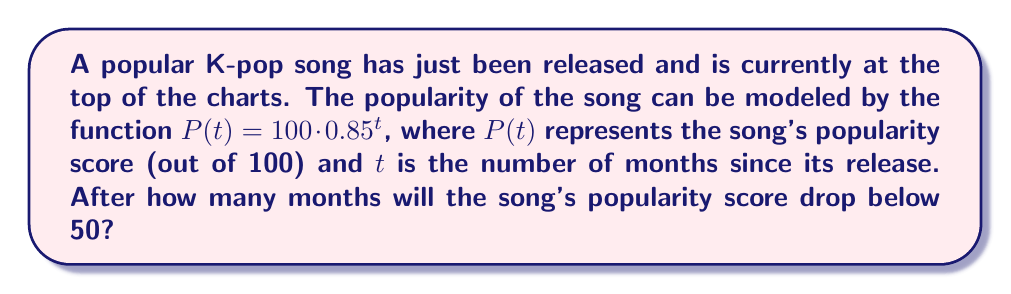Help me with this question. To solve this problem, we need to use logarithms to find the value of $t$ when $P(t) < 50$. Let's follow these steps:

1) We want to find $t$ when $P(t) = 50$, as this is the point where the popularity drops below 50.

2) Set up the equation:
   $50 = 100 \cdot 0.85^t$

3) Divide both sides by 100:
   $0.5 = 0.85^t$

4) Take the natural logarithm of both sides:
   $\ln(0.5) = \ln(0.85^t)$

5) Use the logarithm property $\ln(a^b) = b\ln(a)$:
   $\ln(0.5) = t \cdot \ln(0.85)$

6) Solve for $t$:
   $t = \frac{\ln(0.5)}{\ln(0.85)}$

7) Calculate the result:
   $t \approx 4.27$ months

8) Since we're looking for when the popularity first drops below 50, we need to round up to the next whole month.

Therefore, the song's popularity will drop below 50 after 5 months.
Answer: 5 months 